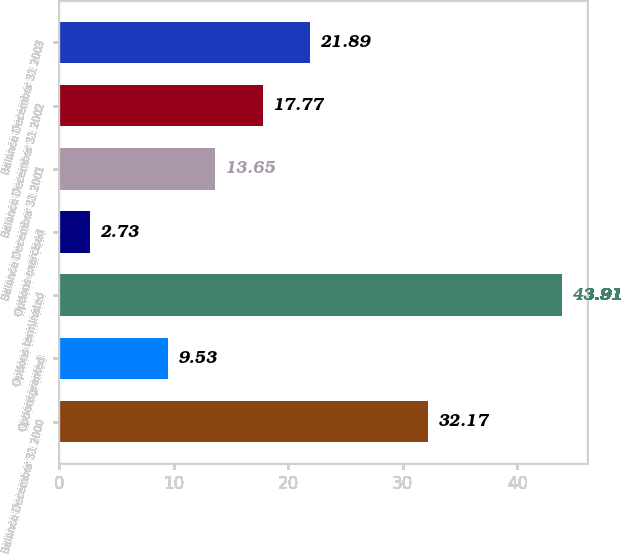Convert chart. <chart><loc_0><loc_0><loc_500><loc_500><bar_chart><fcel>Balance December 31 2000<fcel>Optionsgranted<fcel>Options terminated<fcel>Options exercised<fcel>Balance December 31 2001<fcel>Balance December 31 2002<fcel>Balance December 31 2003<nl><fcel>32.17<fcel>9.53<fcel>43.91<fcel>2.73<fcel>13.65<fcel>17.77<fcel>21.89<nl></chart> 